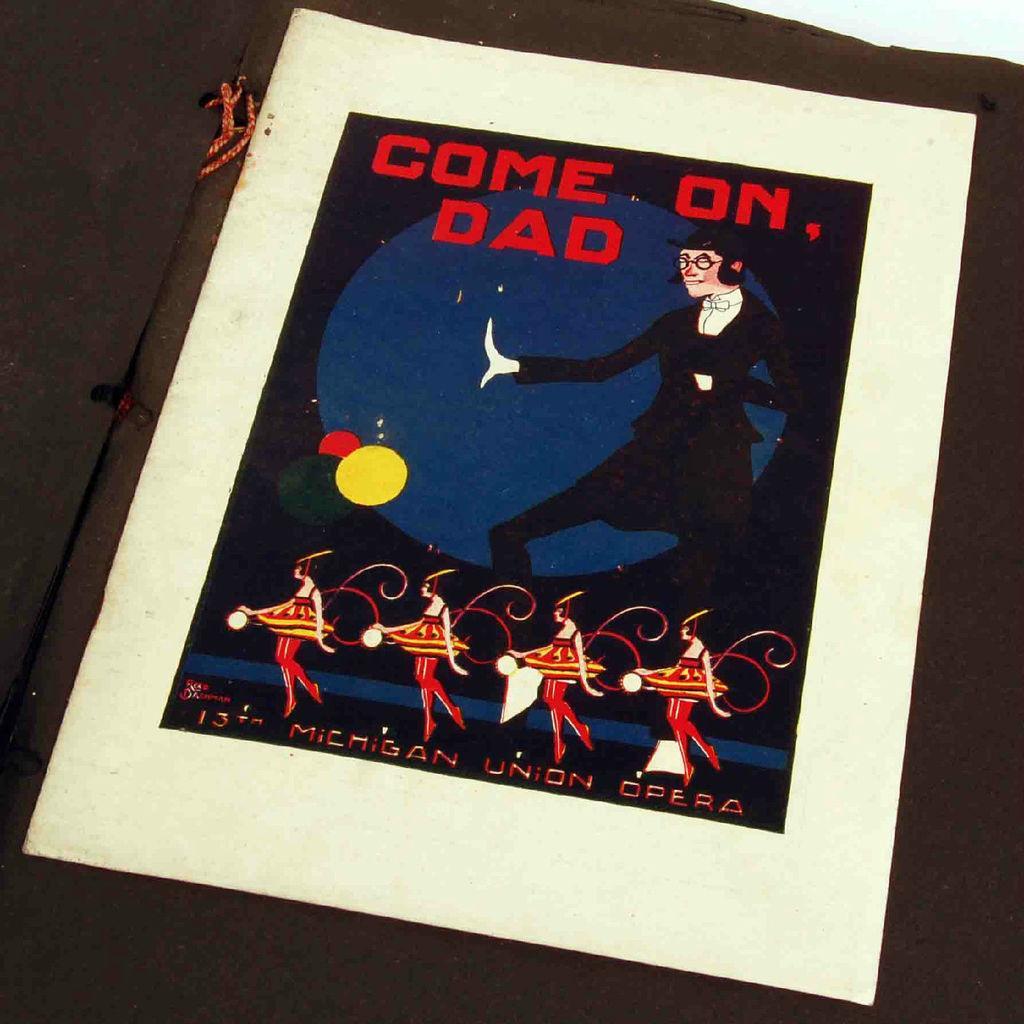Can you describe this image briefly? This is a poster with a text on it as "come on dad" and we can see some cartoons dancing on the poster 